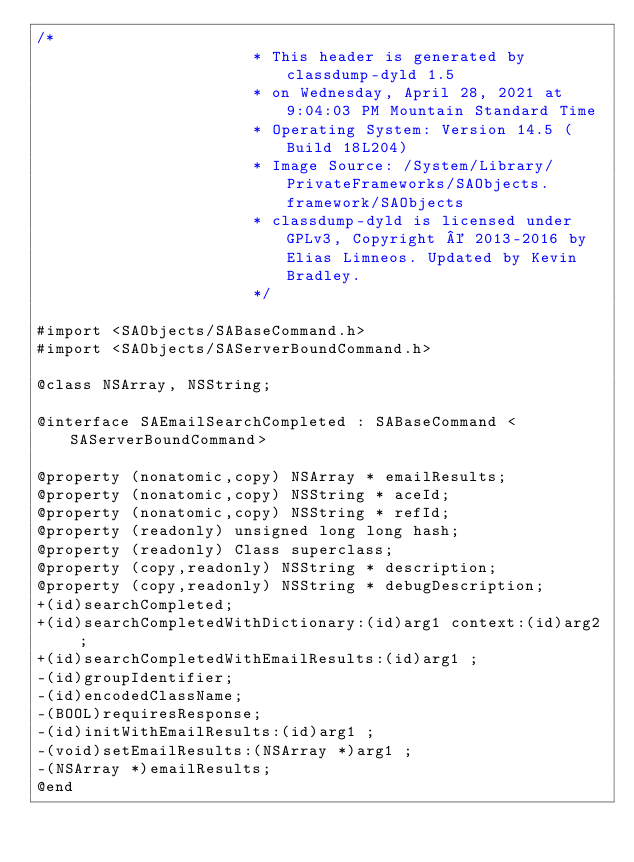<code> <loc_0><loc_0><loc_500><loc_500><_C_>/*
                       * This header is generated by classdump-dyld 1.5
                       * on Wednesday, April 28, 2021 at 9:04:03 PM Mountain Standard Time
                       * Operating System: Version 14.5 (Build 18L204)
                       * Image Source: /System/Library/PrivateFrameworks/SAObjects.framework/SAObjects
                       * classdump-dyld is licensed under GPLv3, Copyright © 2013-2016 by Elias Limneos. Updated by Kevin Bradley.
                       */

#import <SAObjects/SABaseCommand.h>
#import <SAObjects/SAServerBoundCommand.h>

@class NSArray, NSString;

@interface SAEmailSearchCompleted : SABaseCommand <SAServerBoundCommand>

@property (nonatomic,copy) NSArray * emailResults; 
@property (nonatomic,copy) NSString * aceId; 
@property (nonatomic,copy) NSString * refId; 
@property (readonly) unsigned long long hash; 
@property (readonly) Class superclass; 
@property (copy,readonly) NSString * description; 
@property (copy,readonly) NSString * debugDescription; 
+(id)searchCompleted;
+(id)searchCompletedWithDictionary:(id)arg1 context:(id)arg2 ;
+(id)searchCompletedWithEmailResults:(id)arg1 ;
-(id)groupIdentifier;
-(id)encodedClassName;
-(BOOL)requiresResponse;
-(id)initWithEmailResults:(id)arg1 ;
-(void)setEmailResults:(NSArray *)arg1 ;
-(NSArray *)emailResults;
@end

</code> 